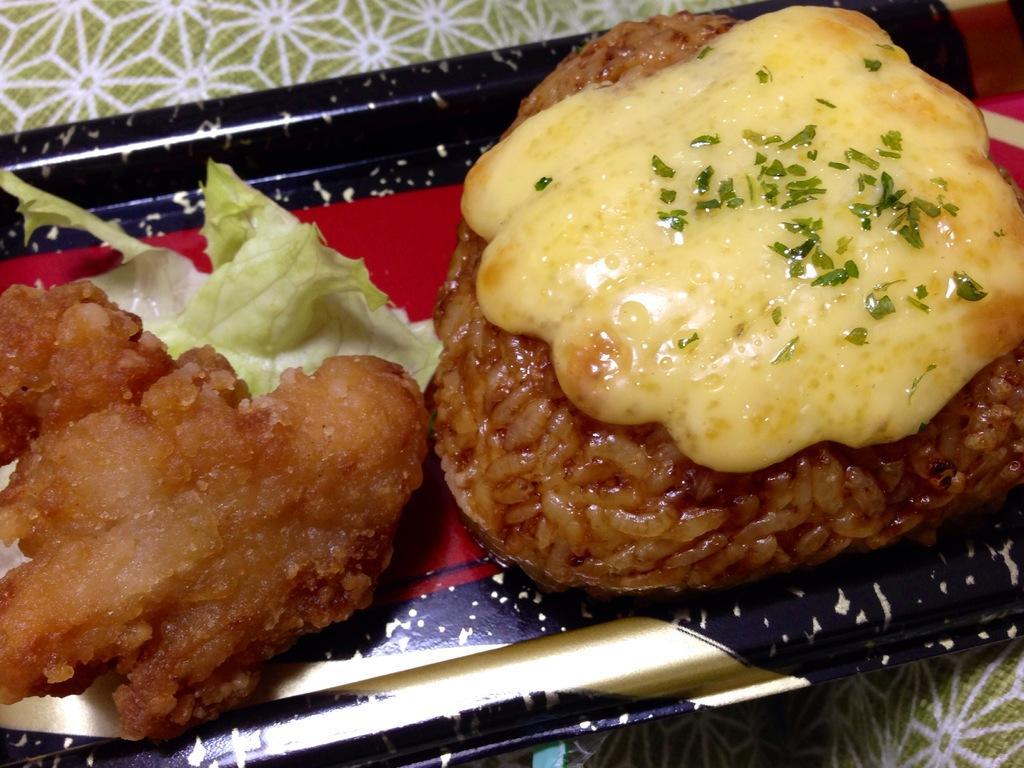Please provide a concise description of this image. In the center of the image there are food items in a plate. At the bottom of the image there is cloth. 